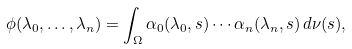<formula> <loc_0><loc_0><loc_500><loc_500>\phi ( \lambda _ { 0 } , \dots , \lambda _ { n } ) = \int _ { \Omega } \alpha _ { 0 } ( \lambda _ { 0 } , s ) \cdots \alpha _ { n } ( \lambda _ { n } , s ) \, d \nu ( s ) ,</formula> 